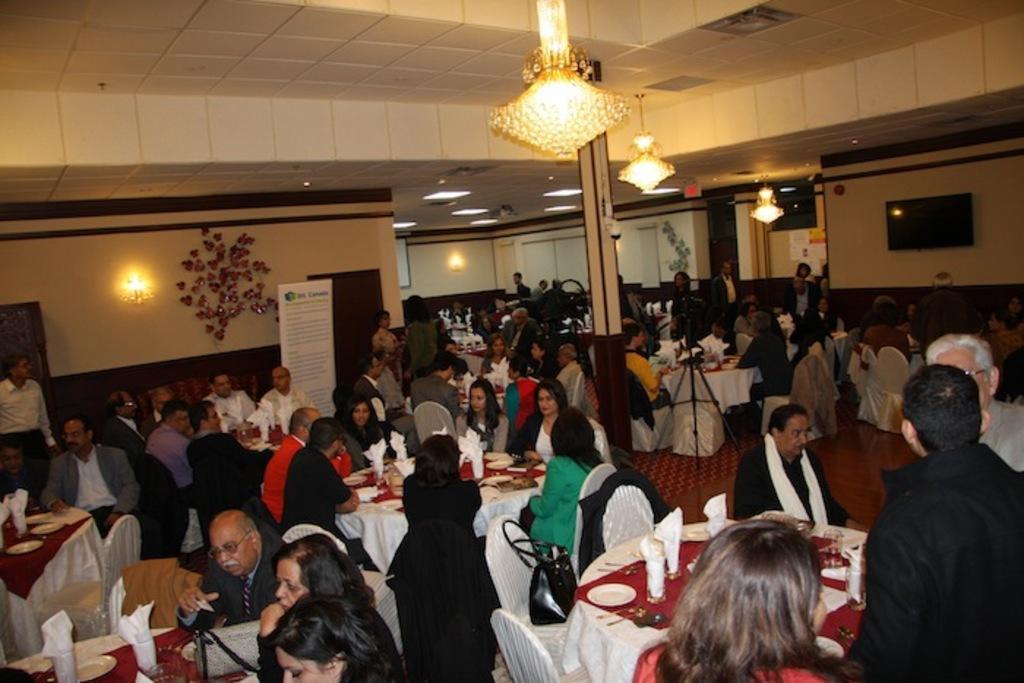Describe this image in one or two sentences. In this image, we can see persons wearing clothes and sitting on chairs in front of tables. There are lights at the top of the image. There is a banner in front of the wall. There is a light on the left side of the image. There is a TV on the right side of the image. 